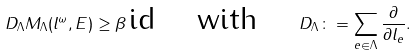Convert formula to latex. <formula><loc_0><loc_0><loc_500><loc_500>D _ { \Lambda } M _ { \Lambda } ( l ^ { \omega } , E ) \geq \beta \, \text {id} \quad \text {   with } \quad D _ { \Lambda } \colon = \sum _ { e \in \Lambda } \frac { \partial } { \partial l _ { e } } .</formula> 